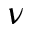Convert formula to latex. <formula><loc_0><loc_0><loc_500><loc_500>\nu</formula> 